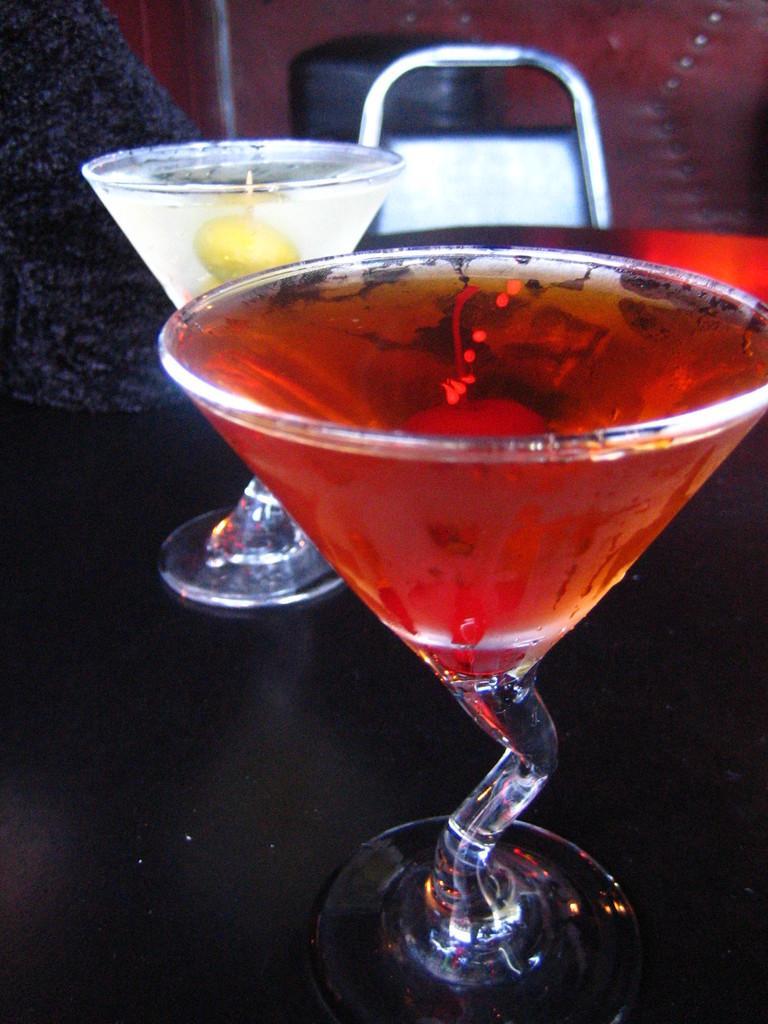In one or two sentences, can you explain what this image depicts? In the center of the image we can see cocktails placed on the table. In the background there is a chair. 